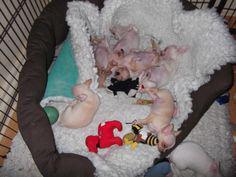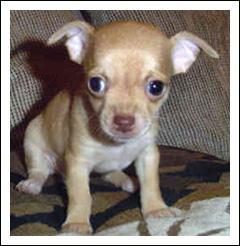The first image is the image on the left, the second image is the image on the right. Given the left and right images, does the statement "Both images show one small dog in a person's hand" hold true? Answer yes or no. No. The first image is the image on the left, the second image is the image on the right. Analyze the images presented: Is the assertion "Each image shows one teacup puppy displayed on a human hand, and the puppy on the right is solid white." valid? Answer yes or no. No. 